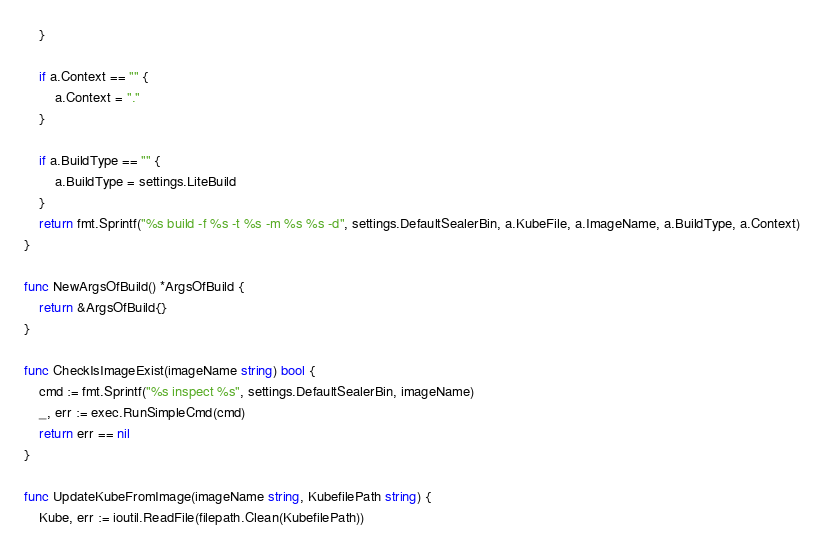<code> <loc_0><loc_0><loc_500><loc_500><_Go_>	}

	if a.Context == "" {
		a.Context = "."
	}

	if a.BuildType == "" {
		a.BuildType = settings.LiteBuild
	}
	return fmt.Sprintf("%s build -f %s -t %s -m %s %s -d", settings.DefaultSealerBin, a.KubeFile, a.ImageName, a.BuildType, a.Context)
}

func NewArgsOfBuild() *ArgsOfBuild {
	return &ArgsOfBuild{}
}

func CheckIsImageExist(imageName string) bool {
	cmd := fmt.Sprintf("%s inspect %s", settings.DefaultSealerBin, imageName)
	_, err := exec.RunSimpleCmd(cmd)
	return err == nil
}

func UpdateKubeFromImage(imageName string, KubefilePath string) {
	Kube, err := ioutil.ReadFile(filepath.Clean(KubefilePath))</code> 